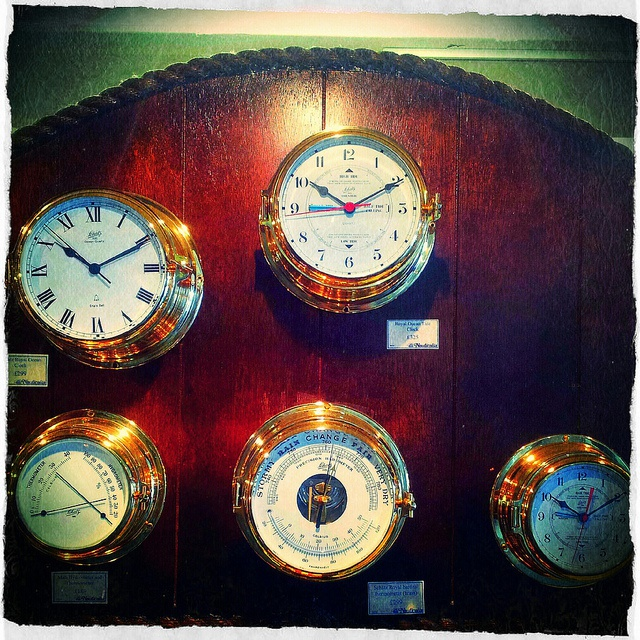Describe the objects in this image and their specific colors. I can see clock in white, beige, maroon, and black tones, clock in white, beige, and darkgray tones, clock in white, black, khaki, olive, and green tones, and clock in white, black, teal, and navy tones in this image. 